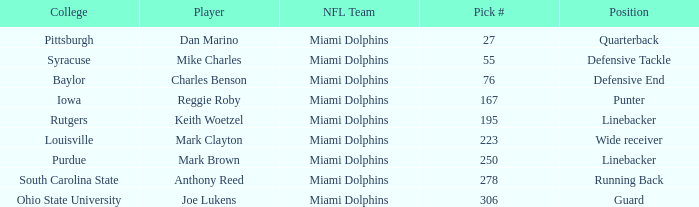If the Position is Running Back what is the Total number of Pick #? 1.0. 